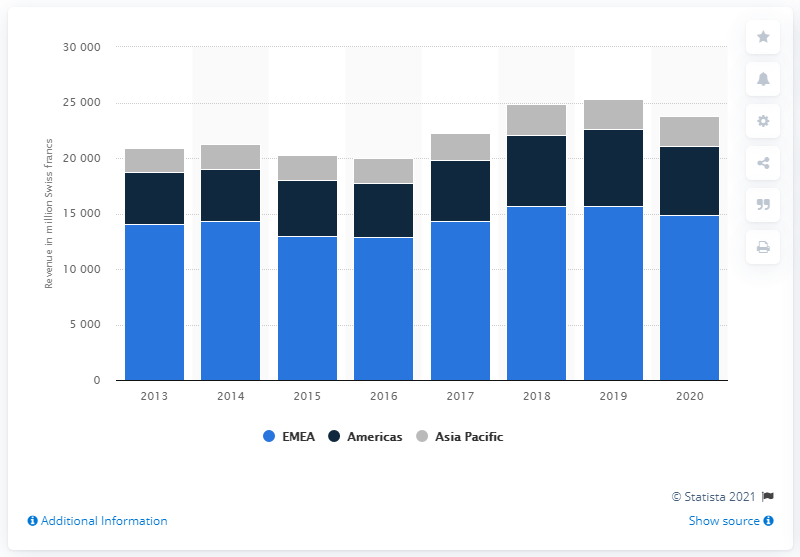Mention a couple of crucial points in this snapshot. In the year 2013, Kuehne + Nagel's fiscal year was. In the fiscal year of 2020, Kuehne + Nagel generated a revenue of 14,830. 